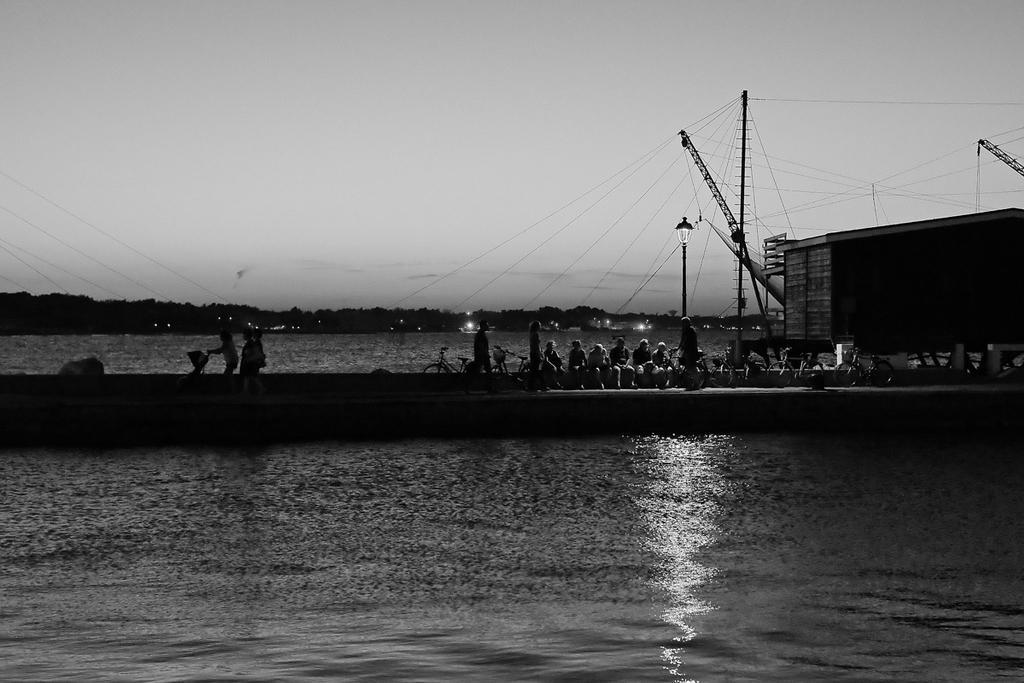Please provide a concise description of this image. We can see water,a far we can see people and bicycles. We can see wall,poles,light and wire. In the background we can see trees and sky. 